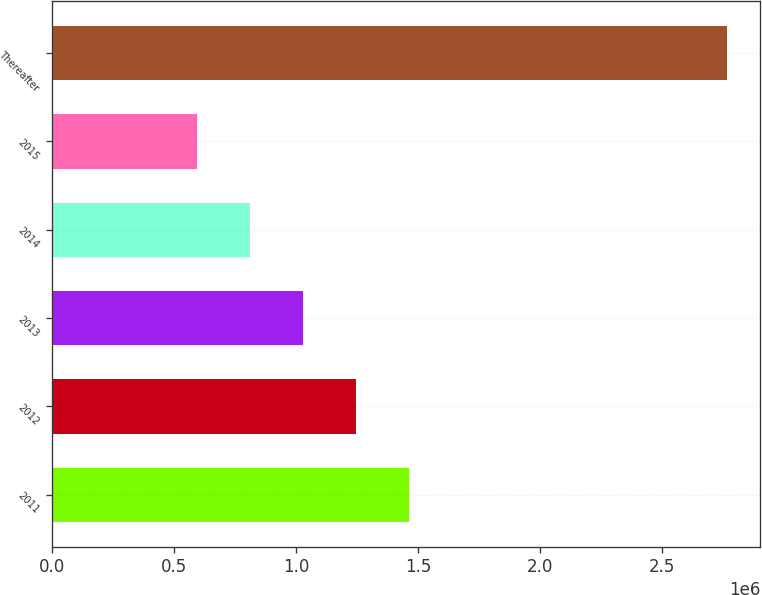Convert chart to OTSL. <chart><loc_0><loc_0><loc_500><loc_500><bar_chart><fcel>2011<fcel>2012<fcel>2013<fcel>2014<fcel>2015<fcel>Thereafter<nl><fcel>1.46154e+06<fcel>1.24401e+06<fcel>1.02648e+06<fcel>808955<fcel>591427<fcel>2.76671e+06<nl></chart> 